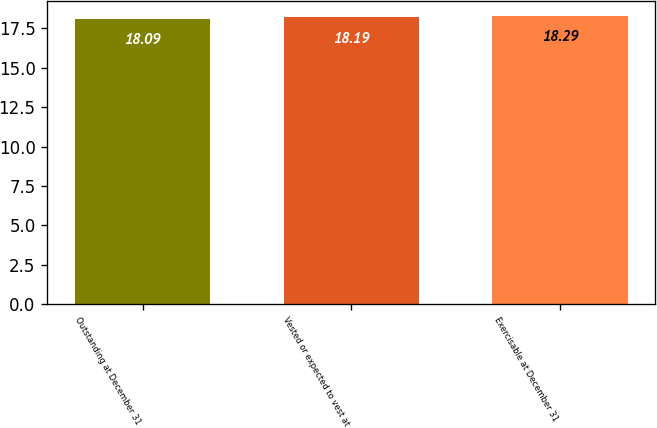Convert chart to OTSL. <chart><loc_0><loc_0><loc_500><loc_500><bar_chart><fcel>Outstanding at December 31<fcel>Vested or expected to vest at<fcel>Exercisable at December 31<nl><fcel>18.09<fcel>18.19<fcel>18.29<nl></chart> 